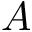<formula> <loc_0><loc_0><loc_500><loc_500>A</formula> 